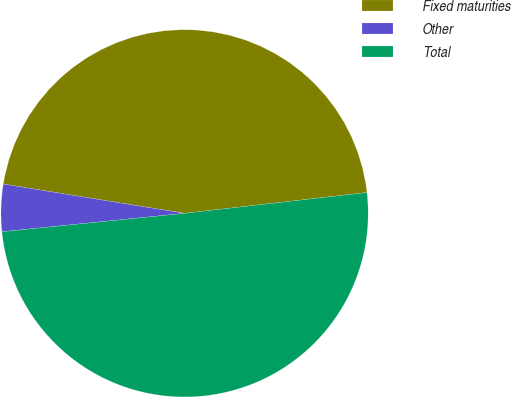Convert chart. <chart><loc_0><loc_0><loc_500><loc_500><pie_chart><fcel>Fixed maturities<fcel>Other<fcel>Total<nl><fcel>45.64%<fcel>4.15%<fcel>50.21%<nl></chart> 